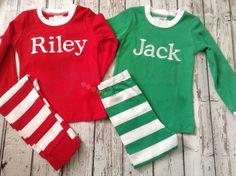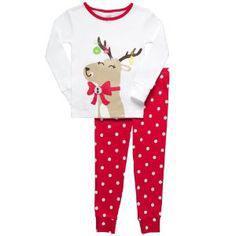The first image is the image on the left, the second image is the image on the right. Analyze the images presented: Is the assertion "One image shows a mostly white top paired with red pants that have white polka dots." valid? Answer yes or no. Yes. The first image is the image on the left, the second image is the image on the right. Given the left and right images, does the statement "There is a reindeer on at least one of the shirts." hold true? Answer yes or no. Yes. 